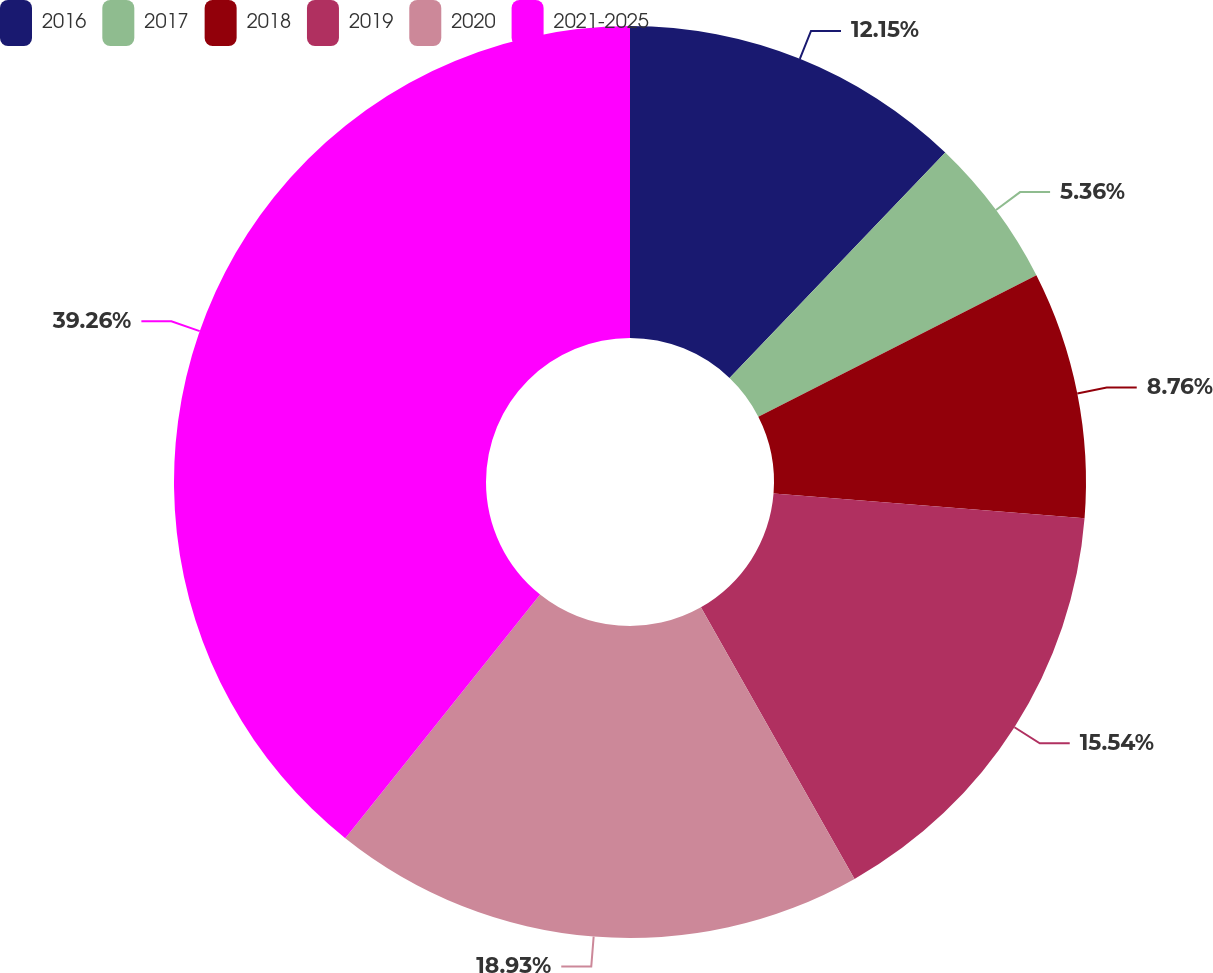Convert chart to OTSL. <chart><loc_0><loc_0><loc_500><loc_500><pie_chart><fcel>2016<fcel>2017<fcel>2018<fcel>2019<fcel>2020<fcel>2021-2025<nl><fcel>12.15%<fcel>5.36%<fcel>8.76%<fcel>15.54%<fcel>18.93%<fcel>39.27%<nl></chart> 